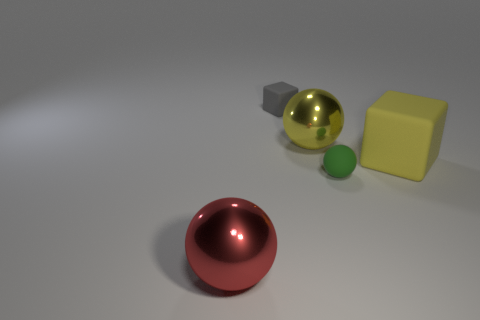Does the tiny cube have the same color as the tiny ball?
Your answer should be very brief. No. What color is the other shiny thing that is the same shape as the large red thing?
Your answer should be compact. Yellow. Do the red object and the small thing to the right of the tiny gray thing have the same material?
Offer a very short reply. No. What shape is the yellow object that is on the right side of the large metallic thing behind the green thing?
Keep it short and to the point. Cube. Is the size of the matte block on the left side of the yellow metallic object the same as the yellow rubber object?
Offer a very short reply. No. How many other objects are there of the same shape as the tiny gray object?
Provide a short and direct response. 1. Does the shiny thing to the left of the small gray rubber cube have the same color as the large cube?
Your answer should be very brief. No. Are there any big metal spheres that have the same color as the small matte cube?
Your answer should be compact. No. There is a matte sphere; how many rubber objects are to the left of it?
Give a very brief answer. 1. How many other objects are there of the same size as the yellow block?
Offer a very short reply. 2. 